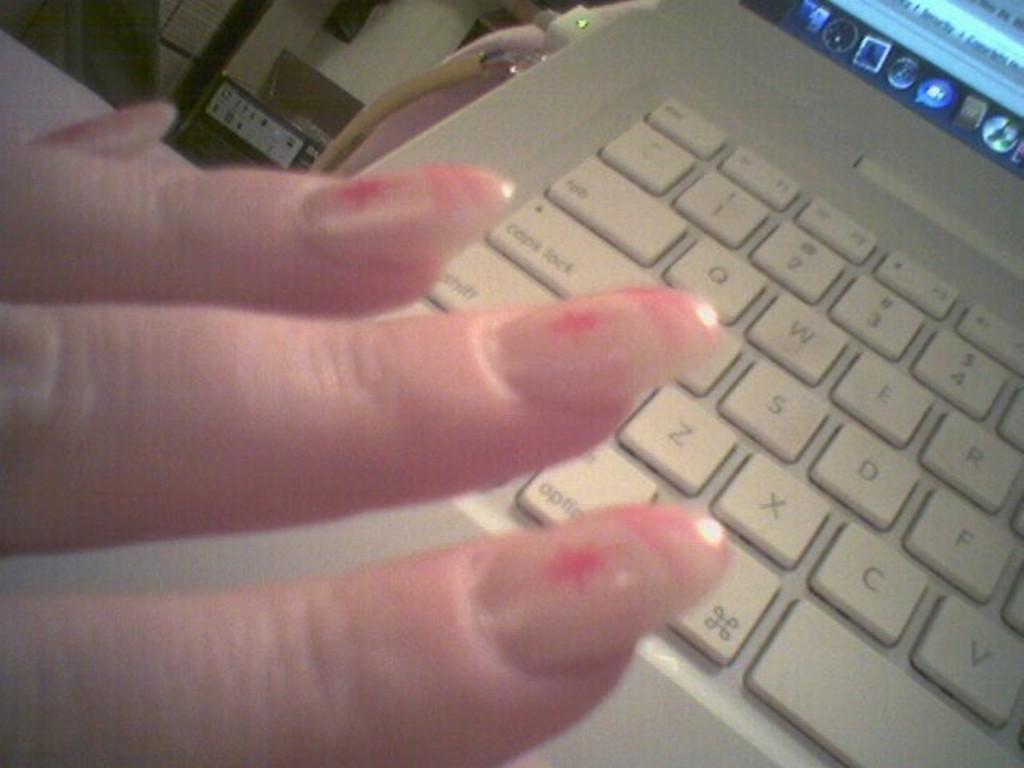What button is to the left of her middle finger nail?
Keep it short and to the point. Caps lock. What key is in the top left corner of the laptop?
Provide a short and direct response. Esc. 